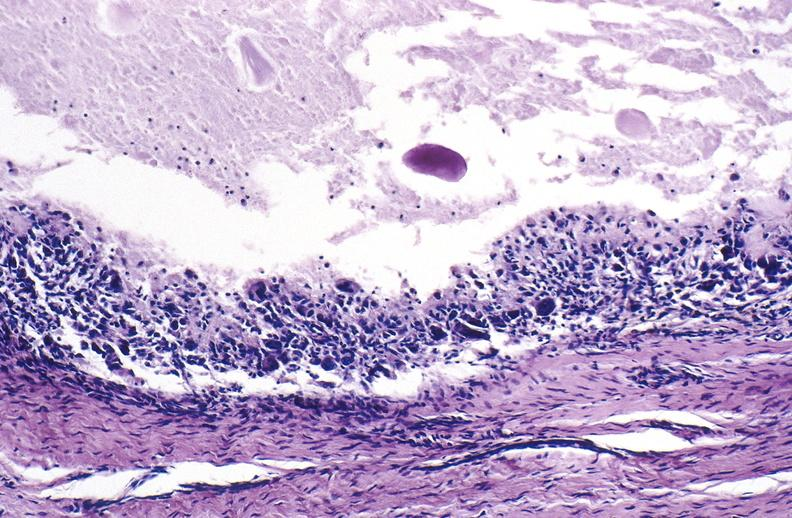does monoclonal gammopathy show gout?
Answer the question using a single word or phrase. No 